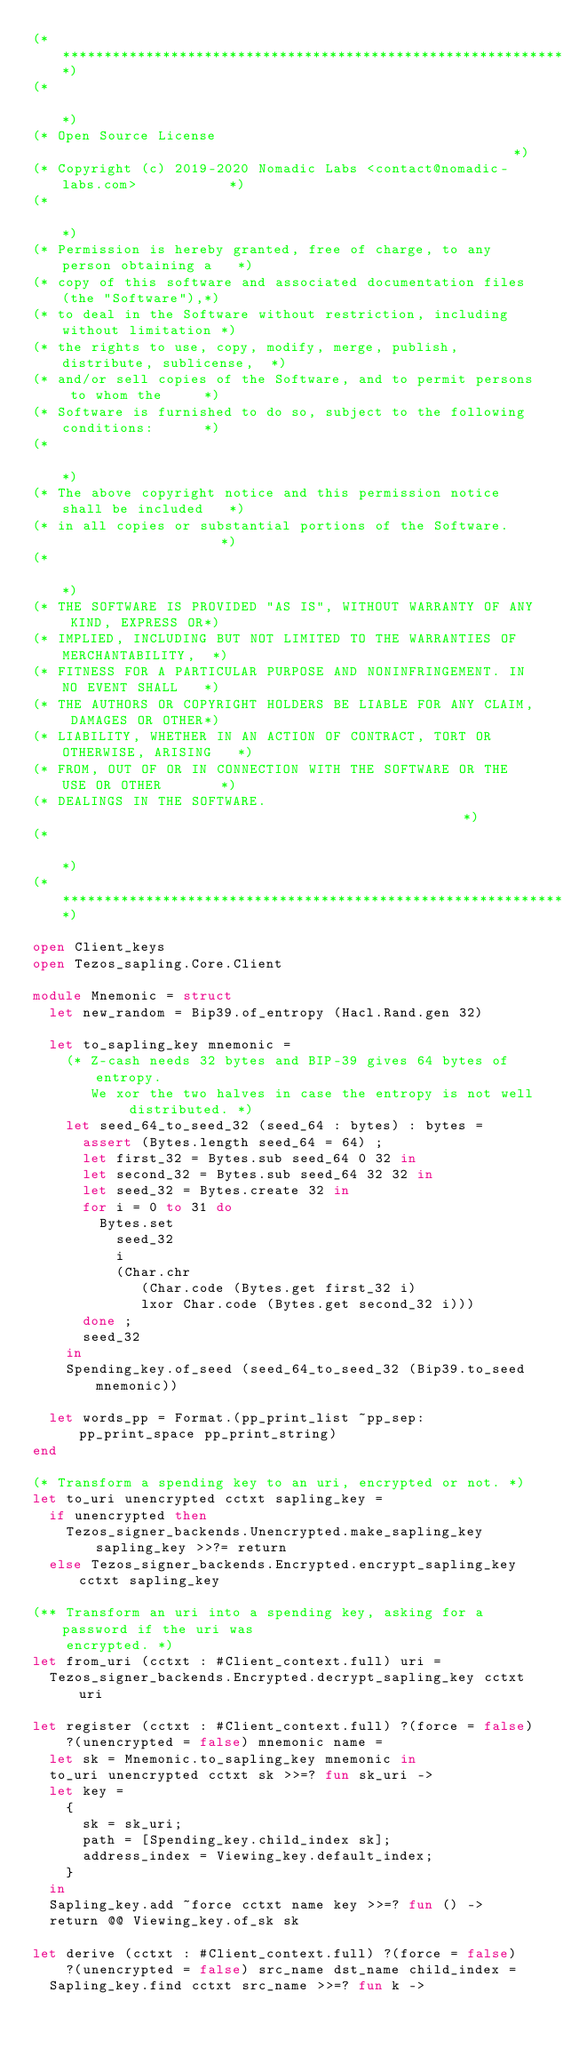<code> <loc_0><loc_0><loc_500><loc_500><_OCaml_>(*****************************************************************************)
(*                                                                           *)
(* Open Source License                                                       *)
(* Copyright (c) 2019-2020 Nomadic Labs <contact@nomadic-labs.com>           *)
(*                                                                           *)
(* Permission is hereby granted, free of charge, to any person obtaining a   *)
(* copy of this software and associated documentation files (the "Software"),*)
(* to deal in the Software without restriction, including without limitation *)
(* the rights to use, copy, modify, merge, publish, distribute, sublicense,  *)
(* and/or sell copies of the Software, and to permit persons to whom the     *)
(* Software is furnished to do so, subject to the following conditions:      *)
(*                                                                           *)
(* The above copyright notice and this permission notice shall be included   *)
(* in all copies or substantial portions of the Software.                    *)
(*                                                                           *)
(* THE SOFTWARE IS PROVIDED "AS IS", WITHOUT WARRANTY OF ANY KIND, EXPRESS OR*)
(* IMPLIED, INCLUDING BUT NOT LIMITED TO THE WARRANTIES OF MERCHANTABILITY,  *)
(* FITNESS FOR A PARTICULAR PURPOSE AND NONINFRINGEMENT. IN NO EVENT SHALL   *)
(* THE AUTHORS OR COPYRIGHT HOLDERS BE LIABLE FOR ANY CLAIM, DAMAGES OR OTHER*)
(* LIABILITY, WHETHER IN AN ACTION OF CONTRACT, TORT OR OTHERWISE, ARISING   *)
(* FROM, OUT OF OR IN CONNECTION WITH THE SOFTWARE OR THE USE OR OTHER       *)
(* DEALINGS IN THE SOFTWARE.                                                 *)
(*                                                                           *)
(*****************************************************************************)

open Client_keys
open Tezos_sapling.Core.Client

module Mnemonic = struct
  let new_random = Bip39.of_entropy (Hacl.Rand.gen 32)

  let to_sapling_key mnemonic =
    (* Z-cash needs 32 bytes and BIP-39 gives 64 bytes of entropy.
       We xor the two halves in case the entropy is not well distributed. *)
    let seed_64_to_seed_32 (seed_64 : bytes) : bytes =
      assert (Bytes.length seed_64 = 64) ;
      let first_32 = Bytes.sub seed_64 0 32 in
      let second_32 = Bytes.sub seed_64 32 32 in
      let seed_32 = Bytes.create 32 in
      for i = 0 to 31 do
        Bytes.set
          seed_32
          i
          (Char.chr
             (Char.code (Bytes.get first_32 i)
             lxor Char.code (Bytes.get second_32 i)))
      done ;
      seed_32
    in
    Spending_key.of_seed (seed_64_to_seed_32 (Bip39.to_seed mnemonic))

  let words_pp = Format.(pp_print_list ~pp_sep:pp_print_space pp_print_string)
end

(* Transform a spending key to an uri, encrypted or not. *)
let to_uri unencrypted cctxt sapling_key =
  if unencrypted then
    Tezos_signer_backends.Unencrypted.make_sapling_key sapling_key >>?= return
  else Tezos_signer_backends.Encrypted.encrypt_sapling_key cctxt sapling_key

(** Transform an uri into a spending key, asking for a password if the uri was
    encrypted. *)
let from_uri (cctxt : #Client_context.full) uri =
  Tezos_signer_backends.Encrypted.decrypt_sapling_key cctxt uri

let register (cctxt : #Client_context.full) ?(force = false)
    ?(unencrypted = false) mnemonic name =
  let sk = Mnemonic.to_sapling_key mnemonic in
  to_uri unencrypted cctxt sk >>=? fun sk_uri ->
  let key =
    {
      sk = sk_uri;
      path = [Spending_key.child_index sk];
      address_index = Viewing_key.default_index;
    }
  in
  Sapling_key.add ~force cctxt name key >>=? fun () ->
  return @@ Viewing_key.of_sk sk

let derive (cctxt : #Client_context.full) ?(force = false)
    ?(unencrypted = false) src_name dst_name child_index =
  Sapling_key.find cctxt src_name >>=? fun k -></code> 